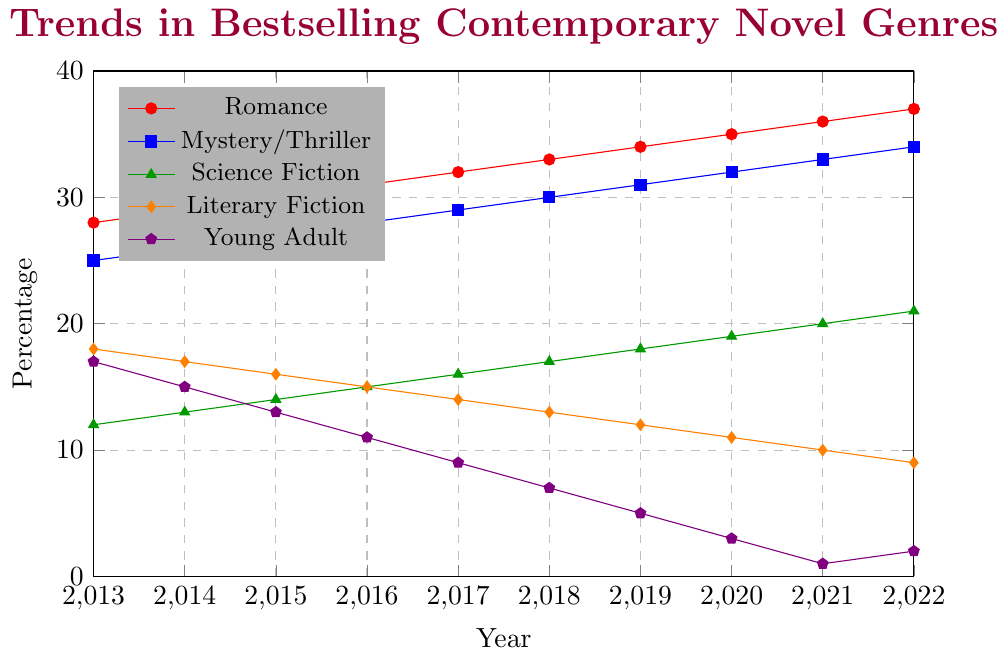What genre had the highest percentage increase over the decade? To determine the highest percentage increase, we need to compare the percentages from 2013 to 2022 for each genre. Romance increased from 28% to 37% (an increase of 9%), Mystery/Thriller from 25% to 34% (an increase of 9%), Science Fiction from 12% to 21% (an increase of 9%), Literary Fiction decreased from 18% to 9% (a decrease of 9%), and Young Adult from 17% to 2% (a decrease of 15%). Thus, the genres Romance, Mystery/Thriller, and Science Fiction all saw the highest increase.
Answer: Romance, Mystery/Thriller, and Science Fiction Which genre consistently decreased over the decade? By visually inspecting the lines on the chart, we can see that both Literary Fiction and Young Adult genres show a consistent downward trend from 2013 to 2022.
Answer: Literary Fiction and Young Adult In which year did Romance surpass 30%? By looking at the pink/orange line representing the Romance genre, it surpassed 30% in 2016.
Answer: 2016 What was the percentage of Science Fiction novels in 2015? Locate the green line that represents Science Fiction and find the point corresponding to the year 2015. The percentage was 14%.
Answer: 14% Compare the percentage of Young Adult novels in 2020 to the percentage in 2013. What is the difference? In 2020, the percentage for Young Adult is 3%, and in 2013, it was 17%. The difference is 17% - 3% = 14%.
Answer: 14% Which genre had the smallest change in percentage over the decade? Compare the changes in percentages by subtracting the 2022 values from the 2013 values for each genre: Romance (37%-28%=9%), Mystery/Thriller (34%-25%=9%), Science Fiction (21%-12%=9%), Literary Fiction (18%-9%=9%), and Young Adult (17%-2%=15%). The genre with the smallest change is Literary Fiction with a change of -9%.
Answer: Literary Fiction How many genres had more than 30% market share in 2020? By looking at the data points for the year 2020, we see that Romance (35%) and Mystery/Thriller (32%) both had more than 30% market share.
Answer: 2 genres In which year did the percentage of Mystery/Thriller novels equal 28%? Locate the blue line representing Mystery/Thriller and find the point where it equals 28%. It is in the year 2016.
Answer: 2016 If you sum up the percentages of all genres in 2017, what is the total? Sum the percentages of all genres in the year 2017: Romance (32), Mystery/Thriller (29), Science Fiction (16), Literary Fiction (14), and Young Adult (9). The total is 32 + 29 + 16 + 14 + 9 = 100%.
Answer: 100% 